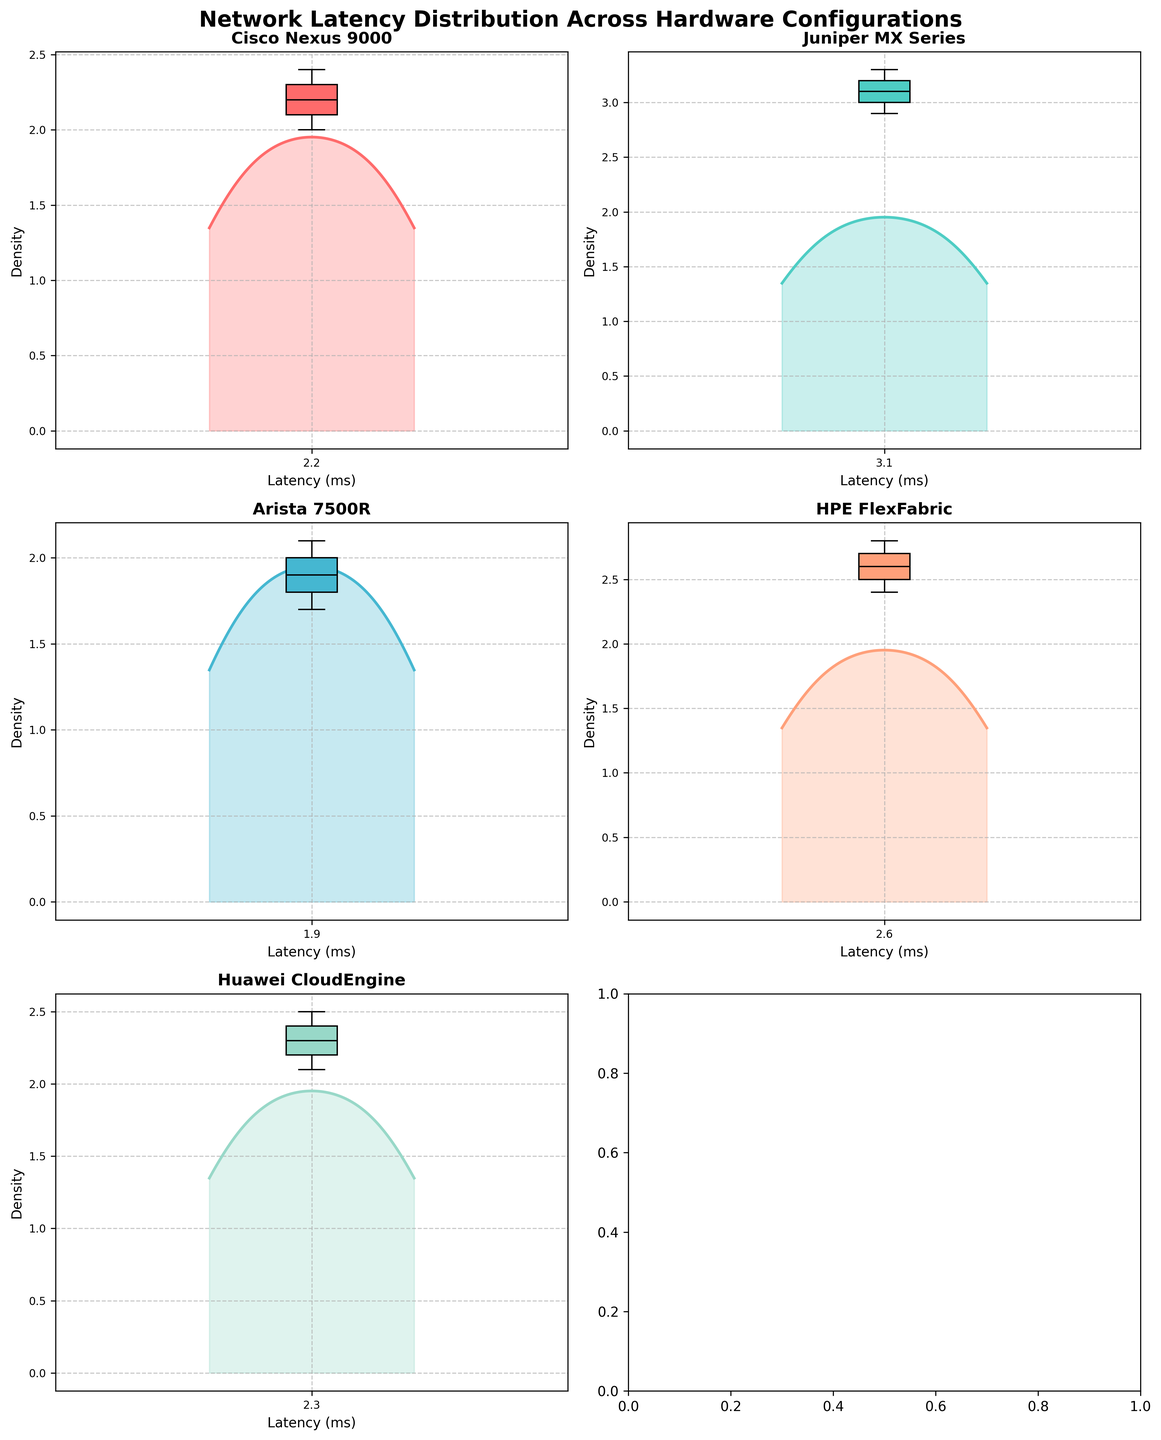Which hardware configuration has the highest peak density in its latency distribution? To determine this, examine the highest point on the density plots for each configuration. Arista 7500R's plot peaks higher than the others.
Answer: Arista 7500R What's the median latency of HPE FlexFabric hardware? The median latency can be observed as the middle line in the boxplot within the density plot. For HPE FlexFabric, this value appears to be around 2.6 ms.
Answer: 2.6 ms Between Cisco Nexus 9000 and Juniper MX Series, which hardware configuration has the wider latency distribution? A wider distribution means more spread in the latency values. By comparing the density plots, Juniper MX Series shows a wider spread than Cisco Nexus 9000.
Answer: Juniper MX Series Do any hardware configurations have overlapping latency ranges? If so, which ones? Overlapping latency ranges can be identified by looking at the x-axes of the density plots. Cisco Nexus 9000 and Huawei CloudEngine have overlapping ranges from about 2.1 to 2.5 ms.
Answer: Cisco Nexus 9000 and Huawei CloudEngine Which hardware configuration has the lowest latency? The plot showing the peak closest to the left indicates the lowest latency. Arista 7500R's plot peaks around 1.7-2.1 ms range, the lowest among all.
Answer: Arista 7500R What is the approximate mean latency of the Juniper MX Series hardware? The mean latency is indicated by the position of the box plot. For Juniper MX Series, this value appears around 3.1 ms.
Answer: 3.1 ms How do the latencies of Cisco Nexus 9000 compare on average with Huawei CloudEngine? By comparing the middle positions of the box plots: Cisco Nexus 9000 has a mean around 2.2 ms, and Huawei CloudEngine around 2.3 ms. Cisco Nexus 9000 has a slightly lower average latency.
Answer: Cisco Nexus 9000 For which hardware configuration is the difference between the highest and lowest latencies the smallest? The smallest difference can be observed in the density plot with the narrowest range. Cisco Nexus 9000 spans approximately from 2.0 to 2.4 ms, making it the smallest range.
Answer: Cisco Nexus 9000 Which configurations show more skewed latency distributions? Skewness can be interpreted by examining asymmetry in the density plots. HPE FlexFabric and Juniper MX Series exhibit more skew than the others.
Answer: HPE FlexFabric and Juniper MX Series 